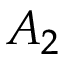Convert formula to latex. <formula><loc_0><loc_0><loc_500><loc_500>A _ { 2 }</formula> 